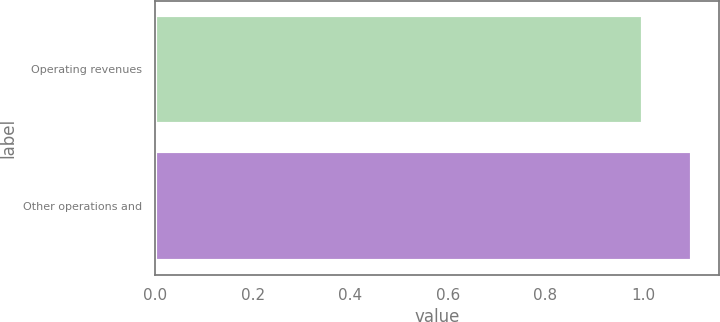Convert chart to OTSL. <chart><loc_0><loc_0><loc_500><loc_500><bar_chart><fcel>Operating revenues<fcel>Other operations and<nl><fcel>1<fcel>1.1<nl></chart> 